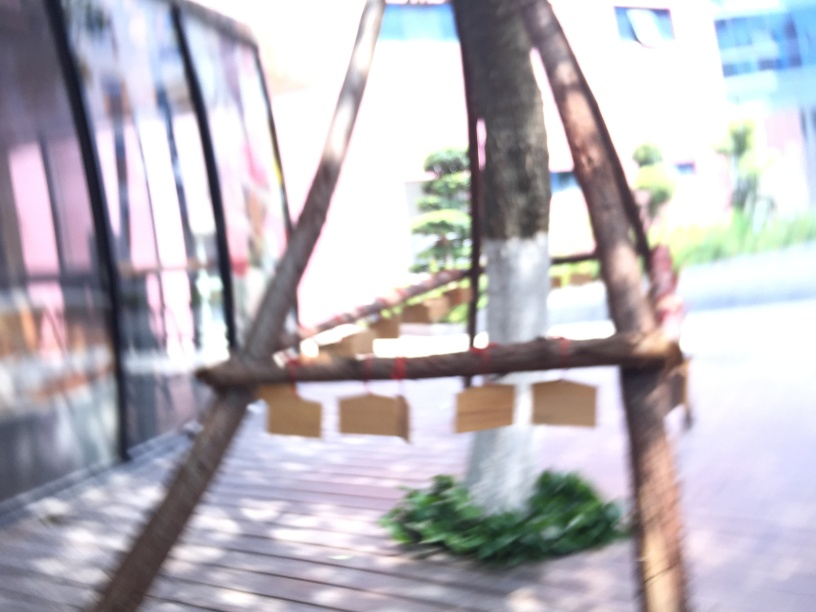Could you suggest any improvements for making the composition of this image better? Improving the composition of this image could involve several steps: ensuring the camera is focused correctly on the subject, using a tripod or stabilizing technique to prevent camera shake, and perhaps changing the angle or perspective to add more depth or interest. Additionally, properly exposing the image and considering compositional rules like the Rule of Thirds might help in creating a more compelling shot. 